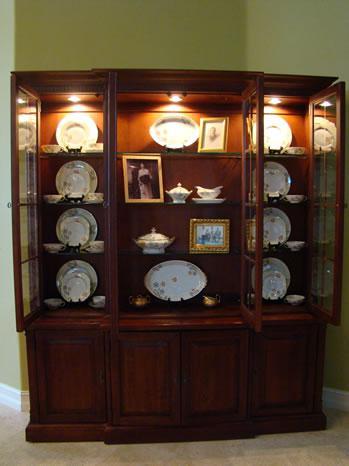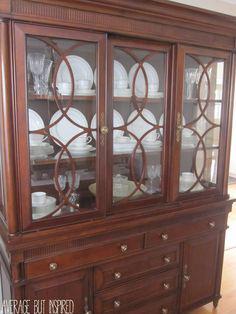The first image is the image on the left, the second image is the image on the right. For the images displayed, is the sentence "All furniture on the images are brown" factually correct? Answer yes or no. Yes. 